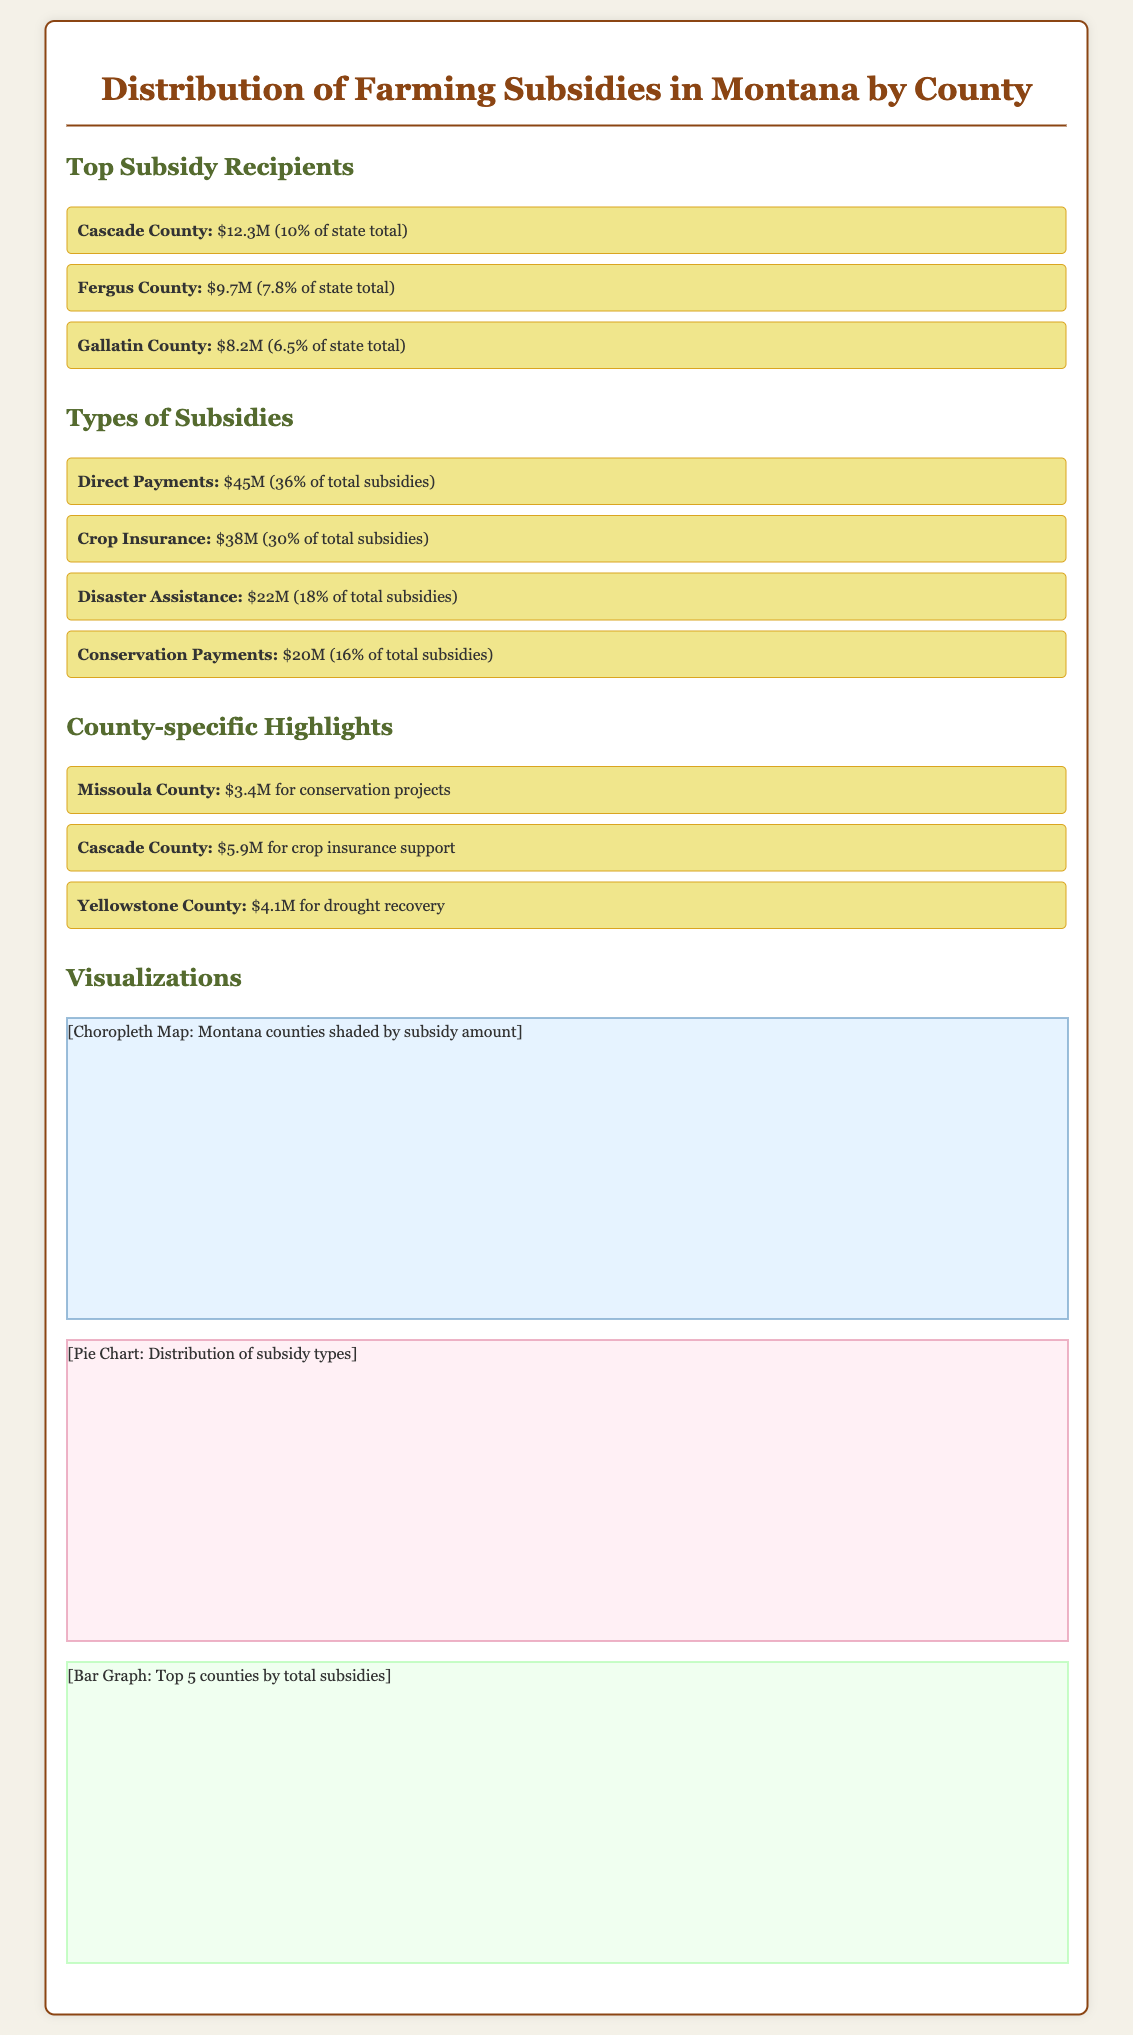What is the total amount of subsidies for Cascade County? The document states that Cascade County received $12.3 million in subsidies.
Answer: $12.3M Which county received the most in subsidies? According to the document, Cascade County is the highest recipient with $12.3 million.
Answer: Cascade County What percentage of the total subsidies does crop insurance represent? The document indicates that crop insurance accounts for 30% of the total subsidies.
Answer: 30% How much did Missoula County receive for conservation projects? The document reveals that Missoula County received $3.4 million for conservation projects.
Answer: $3.4M What type of subsidies received the least funding? The document specifies that conservation payments, totaling $20 million, are lower than others.
Answer: Conservation Payments How much total funding did the top three counties receive? The total of Cascade ($12.3M), Fergus ($9.7M), and Gallatin ($8.2M) is $30.2 million combined.
Answer: $30.2M Which counties received specific funding for drought recovery? Yellowstone County is noted for receiving $4.1 million for drought recovery in the document.
Answer: Yellowstone County What type of visualization is used to illustrate the distribution of subsidy types? The document mentions that a pie chart is used for this purpose.
Answer: Pie Chart Which type of subsidy received the highest amount? The document shows that direct payments received the highest funding at $45 million.
Answer: Direct Payments 